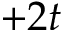Convert formula to latex. <formula><loc_0><loc_0><loc_500><loc_500>+ 2 t</formula> 